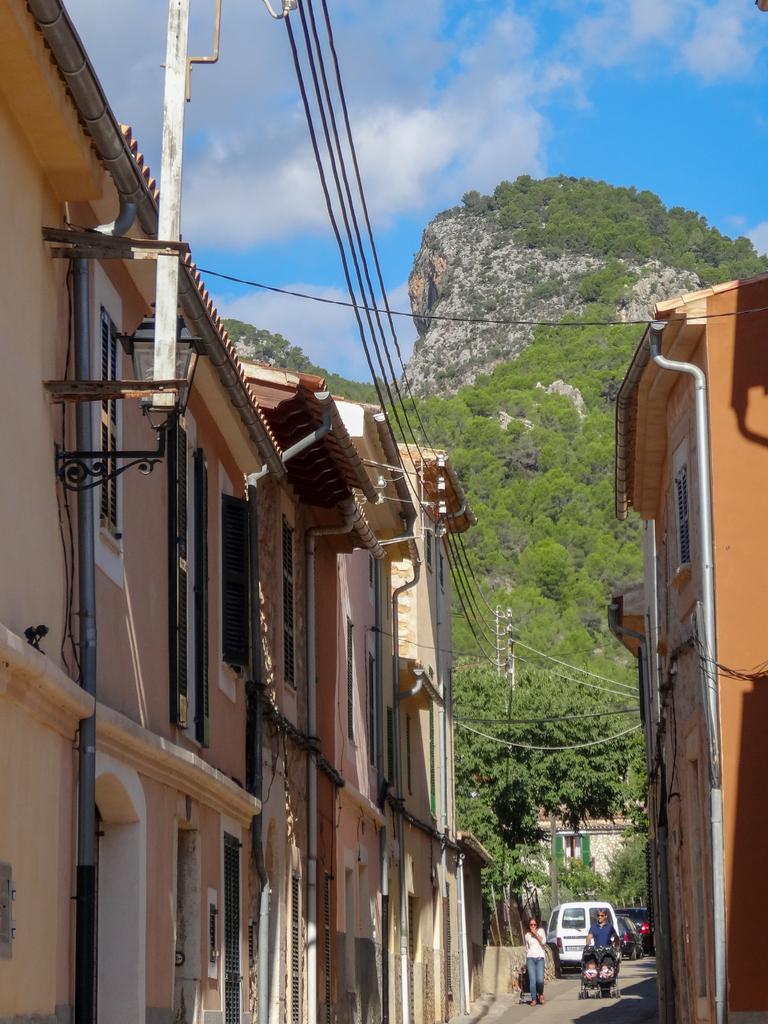How would you summarize this image in a sentence or two? This image is clicked on the road. In the front, we can see two persons and a van. At the bottom, there is a road. On the left and right, there are buildings. In the middle, there is a pole along with wires. In the background, there is a mountain covered with plants and trees. At the top, there are clouds in the sky. 